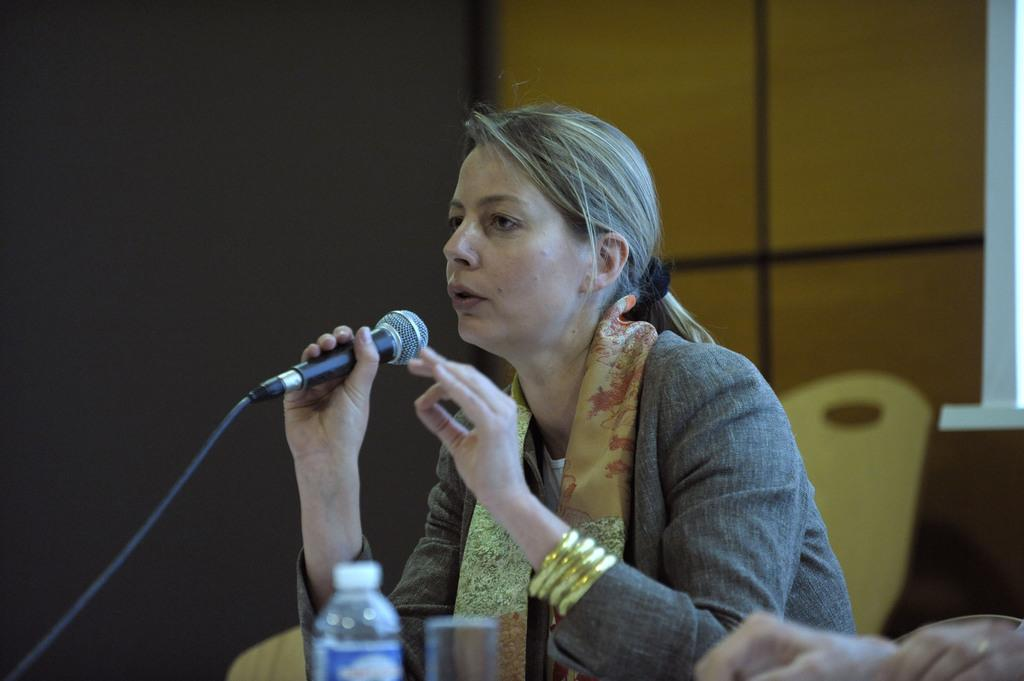Who is present in the image? There is a woman in the image. What is the woman doing in the image? The woman is sitting in the image. What object is the woman holding in her hand? The woman is holding a mic in her hand. Is the woman in jail in the image? There is no indication in the image that the woman is in jail. What type of pest can be seen crawling on the woman in the image? There are no pests visible in the image. 